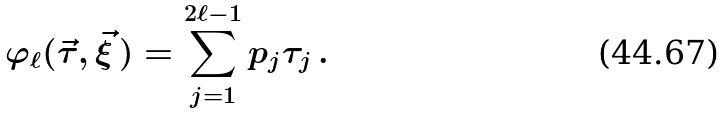Convert formula to latex. <formula><loc_0><loc_0><loc_500><loc_500>\varphi _ { \ell } ( \vec { \tau } , \vec { \xi } \, ) = \sum _ { j = 1 } ^ { 2 \ell - 1 } p _ { j } \tau _ { j } \, .</formula> 